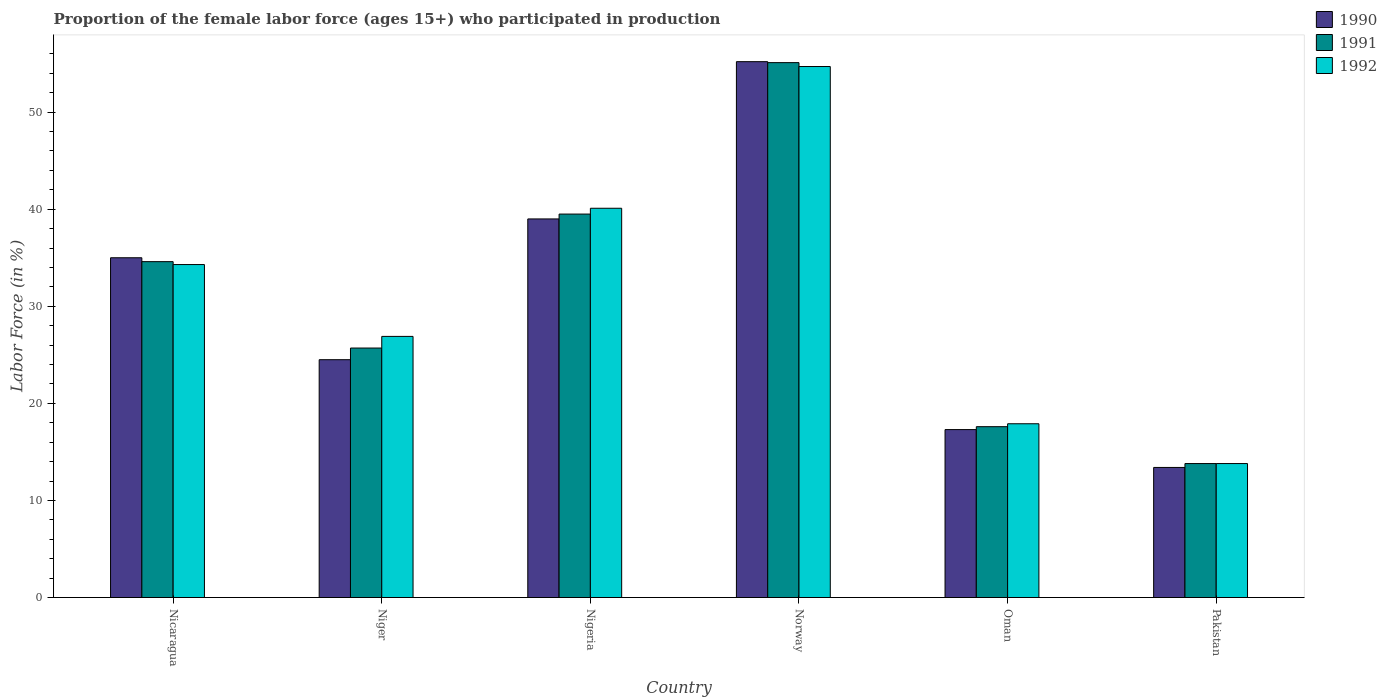How many groups of bars are there?
Offer a very short reply. 6. How many bars are there on the 5th tick from the right?
Provide a succinct answer. 3. What is the label of the 3rd group of bars from the left?
Keep it short and to the point. Nigeria. What is the proportion of the female labor force who participated in production in 1992 in Norway?
Your response must be concise. 54.7. Across all countries, what is the maximum proportion of the female labor force who participated in production in 1991?
Your answer should be compact. 55.1. Across all countries, what is the minimum proportion of the female labor force who participated in production in 1990?
Provide a short and direct response. 13.4. What is the total proportion of the female labor force who participated in production in 1991 in the graph?
Provide a succinct answer. 186.3. What is the difference between the proportion of the female labor force who participated in production in 1992 in Nicaragua and that in Norway?
Offer a very short reply. -20.4. What is the difference between the proportion of the female labor force who participated in production in 1991 in Nigeria and the proportion of the female labor force who participated in production in 1990 in Norway?
Ensure brevity in your answer.  -15.7. What is the average proportion of the female labor force who participated in production in 1992 per country?
Your answer should be very brief. 31.28. What is the difference between the proportion of the female labor force who participated in production of/in 1992 and proportion of the female labor force who participated in production of/in 1991 in Nigeria?
Your answer should be compact. 0.6. What is the ratio of the proportion of the female labor force who participated in production in 1992 in Nicaragua to that in Norway?
Offer a terse response. 0.63. Is the proportion of the female labor force who participated in production in 1992 in Norway less than that in Oman?
Offer a terse response. No. Is the difference between the proportion of the female labor force who participated in production in 1992 in Niger and Pakistan greater than the difference between the proportion of the female labor force who participated in production in 1991 in Niger and Pakistan?
Keep it short and to the point. Yes. What is the difference between the highest and the second highest proportion of the female labor force who participated in production in 1991?
Your answer should be very brief. -4.9. What is the difference between the highest and the lowest proportion of the female labor force who participated in production in 1992?
Make the answer very short. 40.9. How many bars are there?
Keep it short and to the point. 18. How many countries are there in the graph?
Ensure brevity in your answer.  6. What is the difference between two consecutive major ticks on the Y-axis?
Make the answer very short. 10. Does the graph contain any zero values?
Provide a short and direct response. No. Does the graph contain grids?
Keep it short and to the point. No. How are the legend labels stacked?
Provide a succinct answer. Vertical. What is the title of the graph?
Provide a short and direct response. Proportion of the female labor force (ages 15+) who participated in production. Does "1982" appear as one of the legend labels in the graph?
Ensure brevity in your answer.  No. What is the label or title of the X-axis?
Your response must be concise. Country. What is the label or title of the Y-axis?
Ensure brevity in your answer.  Labor Force (in %). What is the Labor Force (in %) of 1991 in Nicaragua?
Keep it short and to the point. 34.6. What is the Labor Force (in %) of 1992 in Nicaragua?
Your answer should be compact. 34.3. What is the Labor Force (in %) of 1991 in Niger?
Keep it short and to the point. 25.7. What is the Labor Force (in %) of 1992 in Niger?
Ensure brevity in your answer.  26.9. What is the Labor Force (in %) of 1991 in Nigeria?
Your answer should be compact. 39.5. What is the Labor Force (in %) of 1992 in Nigeria?
Keep it short and to the point. 40.1. What is the Labor Force (in %) in 1990 in Norway?
Give a very brief answer. 55.2. What is the Labor Force (in %) in 1991 in Norway?
Your answer should be compact. 55.1. What is the Labor Force (in %) of 1992 in Norway?
Keep it short and to the point. 54.7. What is the Labor Force (in %) in 1990 in Oman?
Your response must be concise. 17.3. What is the Labor Force (in %) of 1991 in Oman?
Provide a short and direct response. 17.6. What is the Labor Force (in %) in 1992 in Oman?
Offer a terse response. 17.9. What is the Labor Force (in %) of 1990 in Pakistan?
Provide a short and direct response. 13.4. What is the Labor Force (in %) of 1991 in Pakistan?
Your response must be concise. 13.8. What is the Labor Force (in %) of 1992 in Pakistan?
Your answer should be very brief. 13.8. Across all countries, what is the maximum Labor Force (in %) in 1990?
Your response must be concise. 55.2. Across all countries, what is the maximum Labor Force (in %) in 1991?
Provide a short and direct response. 55.1. Across all countries, what is the maximum Labor Force (in %) of 1992?
Your response must be concise. 54.7. Across all countries, what is the minimum Labor Force (in %) of 1990?
Offer a very short reply. 13.4. Across all countries, what is the minimum Labor Force (in %) in 1991?
Give a very brief answer. 13.8. Across all countries, what is the minimum Labor Force (in %) in 1992?
Ensure brevity in your answer.  13.8. What is the total Labor Force (in %) in 1990 in the graph?
Provide a short and direct response. 184.4. What is the total Labor Force (in %) in 1991 in the graph?
Offer a very short reply. 186.3. What is the total Labor Force (in %) of 1992 in the graph?
Your answer should be very brief. 187.7. What is the difference between the Labor Force (in %) of 1990 in Nicaragua and that in Niger?
Offer a very short reply. 10.5. What is the difference between the Labor Force (in %) in 1992 in Nicaragua and that in Niger?
Make the answer very short. 7.4. What is the difference between the Labor Force (in %) in 1990 in Nicaragua and that in Nigeria?
Your answer should be compact. -4. What is the difference between the Labor Force (in %) of 1992 in Nicaragua and that in Nigeria?
Keep it short and to the point. -5.8. What is the difference between the Labor Force (in %) in 1990 in Nicaragua and that in Norway?
Provide a short and direct response. -20.2. What is the difference between the Labor Force (in %) in 1991 in Nicaragua and that in Norway?
Your answer should be compact. -20.5. What is the difference between the Labor Force (in %) in 1992 in Nicaragua and that in Norway?
Offer a very short reply. -20.4. What is the difference between the Labor Force (in %) in 1990 in Nicaragua and that in Pakistan?
Make the answer very short. 21.6. What is the difference between the Labor Force (in %) of 1991 in Nicaragua and that in Pakistan?
Ensure brevity in your answer.  20.8. What is the difference between the Labor Force (in %) of 1991 in Niger and that in Nigeria?
Ensure brevity in your answer.  -13.8. What is the difference between the Labor Force (in %) in 1992 in Niger and that in Nigeria?
Give a very brief answer. -13.2. What is the difference between the Labor Force (in %) of 1990 in Niger and that in Norway?
Your answer should be very brief. -30.7. What is the difference between the Labor Force (in %) of 1991 in Niger and that in Norway?
Offer a very short reply. -29.4. What is the difference between the Labor Force (in %) in 1992 in Niger and that in Norway?
Your answer should be compact. -27.8. What is the difference between the Labor Force (in %) of 1990 in Niger and that in Oman?
Your response must be concise. 7.2. What is the difference between the Labor Force (in %) of 1990 in Niger and that in Pakistan?
Provide a succinct answer. 11.1. What is the difference between the Labor Force (in %) in 1992 in Niger and that in Pakistan?
Provide a succinct answer. 13.1. What is the difference between the Labor Force (in %) of 1990 in Nigeria and that in Norway?
Provide a succinct answer. -16.2. What is the difference between the Labor Force (in %) in 1991 in Nigeria and that in Norway?
Keep it short and to the point. -15.6. What is the difference between the Labor Force (in %) of 1992 in Nigeria and that in Norway?
Give a very brief answer. -14.6. What is the difference between the Labor Force (in %) of 1990 in Nigeria and that in Oman?
Offer a very short reply. 21.7. What is the difference between the Labor Force (in %) in 1991 in Nigeria and that in Oman?
Your answer should be very brief. 21.9. What is the difference between the Labor Force (in %) in 1990 in Nigeria and that in Pakistan?
Give a very brief answer. 25.6. What is the difference between the Labor Force (in %) of 1991 in Nigeria and that in Pakistan?
Provide a short and direct response. 25.7. What is the difference between the Labor Force (in %) of 1992 in Nigeria and that in Pakistan?
Offer a very short reply. 26.3. What is the difference between the Labor Force (in %) in 1990 in Norway and that in Oman?
Make the answer very short. 37.9. What is the difference between the Labor Force (in %) of 1991 in Norway and that in Oman?
Provide a succinct answer. 37.5. What is the difference between the Labor Force (in %) of 1992 in Norway and that in Oman?
Your answer should be compact. 36.8. What is the difference between the Labor Force (in %) in 1990 in Norway and that in Pakistan?
Give a very brief answer. 41.8. What is the difference between the Labor Force (in %) of 1991 in Norway and that in Pakistan?
Offer a very short reply. 41.3. What is the difference between the Labor Force (in %) in 1992 in Norway and that in Pakistan?
Offer a very short reply. 40.9. What is the difference between the Labor Force (in %) in 1991 in Oman and that in Pakistan?
Offer a terse response. 3.8. What is the difference between the Labor Force (in %) in 1990 in Nicaragua and the Labor Force (in %) in 1992 in Niger?
Your response must be concise. 8.1. What is the difference between the Labor Force (in %) of 1990 in Nicaragua and the Labor Force (in %) of 1991 in Nigeria?
Your response must be concise. -4.5. What is the difference between the Labor Force (in %) in 1991 in Nicaragua and the Labor Force (in %) in 1992 in Nigeria?
Provide a short and direct response. -5.5. What is the difference between the Labor Force (in %) of 1990 in Nicaragua and the Labor Force (in %) of 1991 in Norway?
Provide a succinct answer. -20.1. What is the difference between the Labor Force (in %) of 1990 in Nicaragua and the Labor Force (in %) of 1992 in Norway?
Provide a succinct answer. -19.7. What is the difference between the Labor Force (in %) in 1991 in Nicaragua and the Labor Force (in %) in 1992 in Norway?
Your response must be concise. -20.1. What is the difference between the Labor Force (in %) in 1990 in Nicaragua and the Labor Force (in %) in 1991 in Oman?
Provide a short and direct response. 17.4. What is the difference between the Labor Force (in %) in 1990 in Nicaragua and the Labor Force (in %) in 1991 in Pakistan?
Offer a terse response. 21.2. What is the difference between the Labor Force (in %) in 1990 in Nicaragua and the Labor Force (in %) in 1992 in Pakistan?
Your response must be concise. 21.2. What is the difference between the Labor Force (in %) of 1991 in Nicaragua and the Labor Force (in %) of 1992 in Pakistan?
Give a very brief answer. 20.8. What is the difference between the Labor Force (in %) in 1990 in Niger and the Labor Force (in %) in 1992 in Nigeria?
Provide a succinct answer. -15.6. What is the difference between the Labor Force (in %) in 1991 in Niger and the Labor Force (in %) in 1992 in Nigeria?
Your response must be concise. -14.4. What is the difference between the Labor Force (in %) of 1990 in Niger and the Labor Force (in %) of 1991 in Norway?
Give a very brief answer. -30.6. What is the difference between the Labor Force (in %) in 1990 in Niger and the Labor Force (in %) in 1992 in Norway?
Ensure brevity in your answer.  -30.2. What is the difference between the Labor Force (in %) in 1991 in Niger and the Labor Force (in %) in 1992 in Norway?
Offer a terse response. -29. What is the difference between the Labor Force (in %) of 1991 in Niger and the Labor Force (in %) of 1992 in Oman?
Give a very brief answer. 7.8. What is the difference between the Labor Force (in %) of 1990 in Niger and the Labor Force (in %) of 1991 in Pakistan?
Your answer should be very brief. 10.7. What is the difference between the Labor Force (in %) of 1991 in Niger and the Labor Force (in %) of 1992 in Pakistan?
Give a very brief answer. 11.9. What is the difference between the Labor Force (in %) in 1990 in Nigeria and the Labor Force (in %) in 1991 in Norway?
Your answer should be compact. -16.1. What is the difference between the Labor Force (in %) in 1990 in Nigeria and the Labor Force (in %) in 1992 in Norway?
Give a very brief answer. -15.7. What is the difference between the Labor Force (in %) of 1991 in Nigeria and the Labor Force (in %) of 1992 in Norway?
Your answer should be compact. -15.2. What is the difference between the Labor Force (in %) of 1990 in Nigeria and the Labor Force (in %) of 1991 in Oman?
Offer a terse response. 21.4. What is the difference between the Labor Force (in %) of 1990 in Nigeria and the Labor Force (in %) of 1992 in Oman?
Offer a terse response. 21.1. What is the difference between the Labor Force (in %) in 1991 in Nigeria and the Labor Force (in %) in 1992 in Oman?
Keep it short and to the point. 21.6. What is the difference between the Labor Force (in %) in 1990 in Nigeria and the Labor Force (in %) in 1991 in Pakistan?
Offer a terse response. 25.2. What is the difference between the Labor Force (in %) of 1990 in Nigeria and the Labor Force (in %) of 1992 in Pakistan?
Offer a terse response. 25.2. What is the difference between the Labor Force (in %) in 1991 in Nigeria and the Labor Force (in %) in 1992 in Pakistan?
Ensure brevity in your answer.  25.7. What is the difference between the Labor Force (in %) of 1990 in Norway and the Labor Force (in %) of 1991 in Oman?
Your answer should be compact. 37.6. What is the difference between the Labor Force (in %) in 1990 in Norway and the Labor Force (in %) in 1992 in Oman?
Keep it short and to the point. 37.3. What is the difference between the Labor Force (in %) of 1991 in Norway and the Labor Force (in %) of 1992 in Oman?
Your answer should be very brief. 37.2. What is the difference between the Labor Force (in %) in 1990 in Norway and the Labor Force (in %) in 1991 in Pakistan?
Ensure brevity in your answer.  41.4. What is the difference between the Labor Force (in %) in 1990 in Norway and the Labor Force (in %) in 1992 in Pakistan?
Keep it short and to the point. 41.4. What is the difference between the Labor Force (in %) of 1991 in Norway and the Labor Force (in %) of 1992 in Pakistan?
Provide a short and direct response. 41.3. What is the difference between the Labor Force (in %) of 1990 in Oman and the Labor Force (in %) of 1991 in Pakistan?
Make the answer very short. 3.5. What is the difference between the Labor Force (in %) in 1990 in Oman and the Labor Force (in %) in 1992 in Pakistan?
Keep it short and to the point. 3.5. What is the average Labor Force (in %) in 1990 per country?
Ensure brevity in your answer.  30.73. What is the average Labor Force (in %) in 1991 per country?
Your response must be concise. 31.05. What is the average Labor Force (in %) in 1992 per country?
Your answer should be compact. 31.28. What is the difference between the Labor Force (in %) in 1990 and Labor Force (in %) in 1991 in Nicaragua?
Provide a succinct answer. 0.4. What is the difference between the Labor Force (in %) of 1991 and Labor Force (in %) of 1992 in Nicaragua?
Your answer should be compact. 0.3. What is the difference between the Labor Force (in %) in 1991 and Labor Force (in %) in 1992 in Niger?
Make the answer very short. -1.2. What is the difference between the Labor Force (in %) of 1990 and Labor Force (in %) of 1991 in Nigeria?
Give a very brief answer. -0.5. What is the difference between the Labor Force (in %) in 1990 and Labor Force (in %) in 1992 in Nigeria?
Ensure brevity in your answer.  -1.1. What is the difference between the Labor Force (in %) in 1991 and Labor Force (in %) in 1992 in Nigeria?
Keep it short and to the point. -0.6. What is the difference between the Labor Force (in %) in 1990 and Labor Force (in %) in 1992 in Norway?
Offer a terse response. 0.5. What is the difference between the Labor Force (in %) in 1991 and Labor Force (in %) in 1992 in Norway?
Offer a very short reply. 0.4. What is the difference between the Labor Force (in %) of 1990 and Labor Force (in %) of 1991 in Oman?
Your answer should be very brief. -0.3. What is the difference between the Labor Force (in %) of 1990 and Labor Force (in %) of 1992 in Oman?
Provide a short and direct response. -0.6. What is the difference between the Labor Force (in %) in 1990 and Labor Force (in %) in 1991 in Pakistan?
Your response must be concise. -0.4. What is the difference between the Labor Force (in %) in 1990 and Labor Force (in %) in 1992 in Pakistan?
Provide a succinct answer. -0.4. What is the difference between the Labor Force (in %) of 1991 and Labor Force (in %) of 1992 in Pakistan?
Keep it short and to the point. 0. What is the ratio of the Labor Force (in %) in 1990 in Nicaragua to that in Niger?
Provide a succinct answer. 1.43. What is the ratio of the Labor Force (in %) in 1991 in Nicaragua to that in Niger?
Give a very brief answer. 1.35. What is the ratio of the Labor Force (in %) of 1992 in Nicaragua to that in Niger?
Give a very brief answer. 1.28. What is the ratio of the Labor Force (in %) of 1990 in Nicaragua to that in Nigeria?
Ensure brevity in your answer.  0.9. What is the ratio of the Labor Force (in %) in 1991 in Nicaragua to that in Nigeria?
Offer a terse response. 0.88. What is the ratio of the Labor Force (in %) in 1992 in Nicaragua to that in Nigeria?
Offer a very short reply. 0.86. What is the ratio of the Labor Force (in %) in 1990 in Nicaragua to that in Norway?
Ensure brevity in your answer.  0.63. What is the ratio of the Labor Force (in %) of 1991 in Nicaragua to that in Norway?
Give a very brief answer. 0.63. What is the ratio of the Labor Force (in %) of 1992 in Nicaragua to that in Norway?
Your answer should be compact. 0.63. What is the ratio of the Labor Force (in %) of 1990 in Nicaragua to that in Oman?
Your answer should be very brief. 2.02. What is the ratio of the Labor Force (in %) in 1991 in Nicaragua to that in Oman?
Keep it short and to the point. 1.97. What is the ratio of the Labor Force (in %) of 1992 in Nicaragua to that in Oman?
Your response must be concise. 1.92. What is the ratio of the Labor Force (in %) of 1990 in Nicaragua to that in Pakistan?
Keep it short and to the point. 2.61. What is the ratio of the Labor Force (in %) in 1991 in Nicaragua to that in Pakistan?
Provide a short and direct response. 2.51. What is the ratio of the Labor Force (in %) of 1992 in Nicaragua to that in Pakistan?
Your response must be concise. 2.49. What is the ratio of the Labor Force (in %) of 1990 in Niger to that in Nigeria?
Your response must be concise. 0.63. What is the ratio of the Labor Force (in %) of 1991 in Niger to that in Nigeria?
Your answer should be compact. 0.65. What is the ratio of the Labor Force (in %) in 1992 in Niger to that in Nigeria?
Your answer should be very brief. 0.67. What is the ratio of the Labor Force (in %) in 1990 in Niger to that in Norway?
Your answer should be compact. 0.44. What is the ratio of the Labor Force (in %) of 1991 in Niger to that in Norway?
Your answer should be compact. 0.47. What is the ratio of the Labor Force (in %) in 1992 in Niger to that in Norway?
Your answer should be very brief. 0.49. What is the ratio of the Labor Force (in %) of 1990 in Niger to that in Oman?
Your answer should be compact. 1.42. What is the ratio of the Labor Force (in %) in 1991 in Niger to that in Oman?
Offer a terse response. 1.46. What is the ratio of the Labor Force (in %) in 1992 in Niger to that in Oman?
Ensure brevity in your answer.  1.5. What is the ratio of the Labor Force (in %) of 1990 in Niger to that in Pakistan?
Ensure brevity in your answer.  1.83. What is the ratio of the Labor Force (in %) in 1991 in Niger to that in Pakistan?
Give a very brief answer. 1.86. What is the ratio of the Labor Force (in %) of 1992 in Niger to that in Pakistan?
Provide a short and direct response. 1.95. What is the ratio of the Labor Force (in %) of 1990 in Nigeria to that in Norway?
Provide a succinct answer. 0.71. What is the ratio of the Labor Force (in %) in 1991 in Nigeria to that in Norway?
Make the answer very short. 0.72. What is the ratio of the Labor Force (in %) of 1992 in Nigeria to that in Norway?
Your answer should be compact. 0.73. What is the ratio of the Labor Force (in %) in 1990 in Nigeria to that in Oman?
Offer a very short reply. 2.25. What is the ratio of the Labor Force (in %) in 1991 in Nigeria to that in Oman?
Offer a terse response. 2.24. What is the ratio of the Labor Force (in %) in 1992 in Nigeria to that in Oman?
Your answer should be compact. 2.24. What is the ratio of the Labor Force (in %) in 1990 in Nigeria to that in Pakistan?
Provide a short and direct response. 2.91. What is the ratio of the Labor Force (in %) in 1991 in Nigeria to that in Pakistan?
Give a very brief answer. 2.86. What is the ratio of the Labor Force (in %) of 1992 in Nigeria to that in Pakistan?
Offer a very short reply. 2.91. What is the ratio of the Labor Force (in %) of 1990 in Norway to that in Oman?
Give a very brief answer. 3.19. What is the ratio of the Labor Force (in %) of 1991 in Norway to that in Oman?
Offer a very short reply. 3.13. What is the ratio of the Labor Force (in %) in 1992 in Norway to that in Oman?
Ensure brevity in your answer.  3.06. What is the ratio of the Labor Force (in %) of 1990 in Norway to that in Pakistan?
Your answer should be very brief. 4.12. What is the ratio of the Labor Force (in %) of 1991 in Norway to that in Pakistan?
Your response must be concise. 3.99. What is the ratio of the Labor Force (in %) in 1992 in Norway to that in Pakistan?
Provide a succinct answer. 3.96. What is the ratio of the Labor Force (in %) in 1990 in Oman to that in Pakistan?
Your answer should be very brief. 1.29. What is the ratio of the Labor Force (in %) of 1991 in Oman to that in Pakistan?
Keep it short and to the point. 1.28. What is the ratio of the Labor Force (in %) in 1992 in Oman to that in Pakistan?
Give a very brief answer. 1.3. What is the difference between the highest and the second highest Labor Force (in %) of 1991?
Ensure brevity in your answer.  15.6. What is the difference between the highest and the second highest Labor Force (in %) of 1992?
Offer a terse response. 14.6. What is the difference between the highest and the lowest Labor Force (in %) of 1990?
Provide a succinct answer. 41.8. What is the difference between the highest and the lowest Labor Force (in %) of 1991?
Offer a very short reply. 41.3. What is the difference between the highest and the lowest Labor Force (in %) of 1992?
Give a very brief answer. 40.9. 